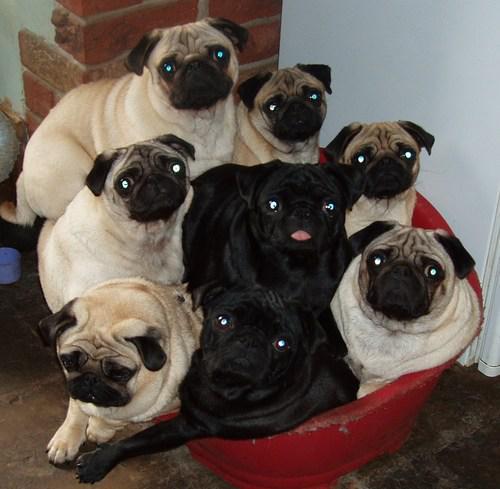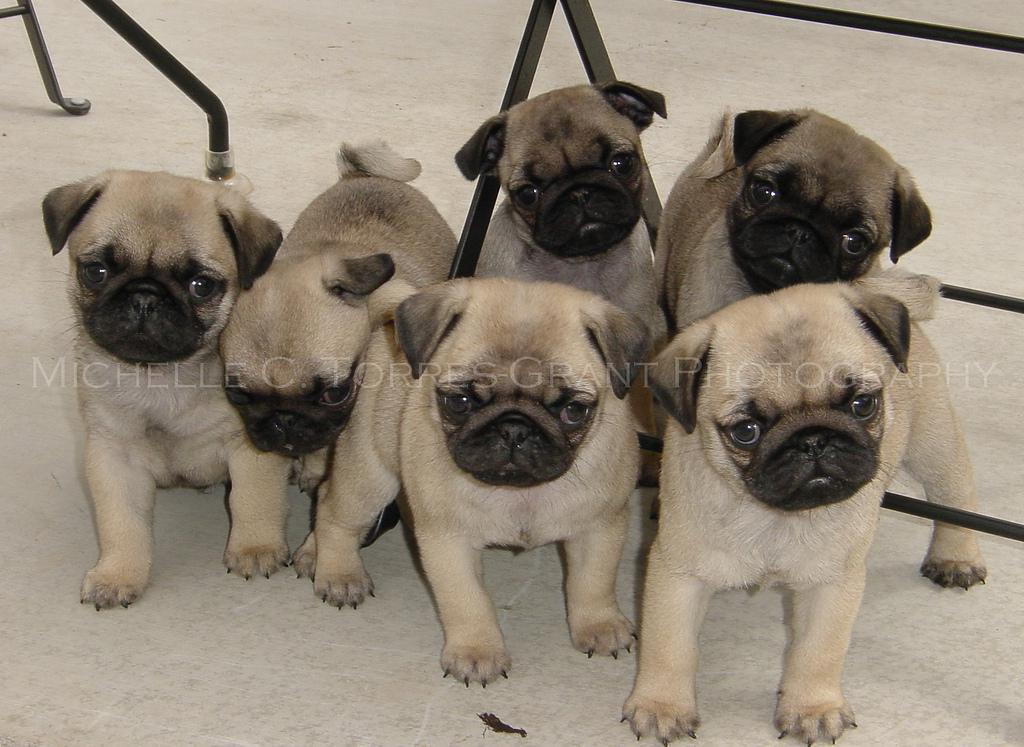The first image is the image on the left, the second image is the image on the right. Evaluate the accuracy of this statement regarding the images: "There are no more than four puppies in the image on the right.". Is it true? Answer yes or no. No. The first image is the image on the left, the second image is the image on the right. Given the left and right images, does the statement "At least one image includes black pugs." hold true? Answer yes or no. Yes. 